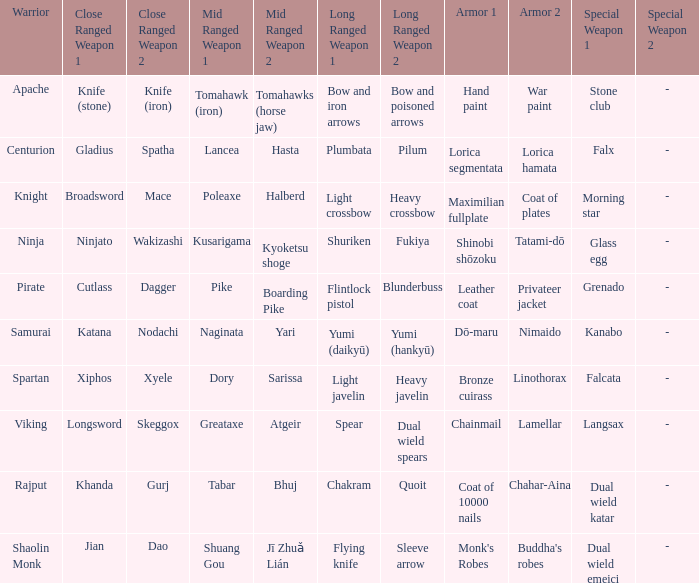If the exceptional weapon is glass egg, what is the close-combat weapon? Ninjato , Wakizashi. Would you mind parsing the complete table? {'header': ['Warrior', 'Close Ranged Weapon 1', 'Close Ranged Weapon 2', 'Mid Ranged Weapon 1', 'Mid Ranged Weapon 2', 'Long Ranged Weapon 1', 'Long Ranged Weapon 2', 'Armor 1', 'Armor 2', 'Special Weapon 1', 'Special Weapon 2'], 'rows': [['Apache', 'Knife (stone)', 'Knife (iron)', 'Tomahawk (iron)', 'Tomahawks (horse jaw)', 'Bow and iron arrows', 'Bow and poisoned arrows', 'Hand paint', 'War paint', 'Stone club', '-'], ['Centurion', 'Gladius', 'Spatha', 'Lancea', 'Hasta', 'Plumbata', 'Pilum', 'Lorica segmentata', 'Lorica hamata', 'Falx', '-'], ['Knight', 'Broadsword', 'Mace', 'Poleaxe', 'Halberd', 'Light crossbow', 'Heavy crossbow', 'Maximilian fullplate', 'Coat of plates', 'Morning star', '-'], ['Ninja', 'Ninjato', 'Wakizashi', 'Kusarigama', 'Kyoketsu shoge', 'Shuriken', 'Fukiya', 'Shinobi shōzoku', 'Tatami-dō', 'Glass egg', '-'], ['Pirate', 'Cutlass', 'Dagger', 'Pike', 'Boarding Pike', 'Flintlock pistol', 'Blunderbuss', 'Leather coat', 'Privateer jacket', 'Grenado', '-'], ['Samurai', 'Katana', 'Nodachi', 'Naginata', 'Yari', 'Yumi (daikyū)', 'Yumi (hankyū)', 'Dō-maru', 'Nimaido', 'Kanabo', '-'], ['Spartan', 'Xiphos', 'Xyele', 'Dory', 'Sarissa', 'Light javelin', 'Heavy javelin', 'Bronze cuirass', 'Linothorax', 'Falcata', '-'], ['Viking', 'Longsword', 'Skeggox', 'Greataxe', 'Atgeir', 'Spear', 'Dual wield spears', 'Chainmail', 'Lamellar', 'Langsax', '-'], ['Rajput', 'Khanda', 'Gurj', 'Tabar', 'Bhuj', 'Chakram', 'Quoit', 'Coat of 10000 nails', 'Chahar-Aina', 'Dual wield katar', '-'], ['Shaolin Monk', 'Jian', 'Dao', 'Shuang Gou', 'Jī Zhuǎ Lián', 'Flying knife', 'Sleeve arrow', "Monk's Robes", "Buddha's robes", 'Dual wield emeici', '-']]} 